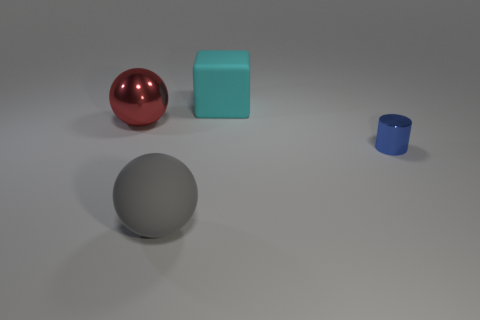Add 1 large cyan matte cubes. How many objects exist? 5 Subtract all cubes. How many objects are left? 3 Subtract 1 balls. How many balls are left? 1 Add 3 cyan matte objects. How many cyan matte objects are left? 4 Add 3 tiny objects. How many tiny objects exist? 4 Subtract 0 green blocks. How many objects are left? 4 Subtract all red cylinders. Subtract all brown balls. How many cylinders are left? 1 Subtract all purple cubes. Subtract all spheres. How many objects are left? 2 